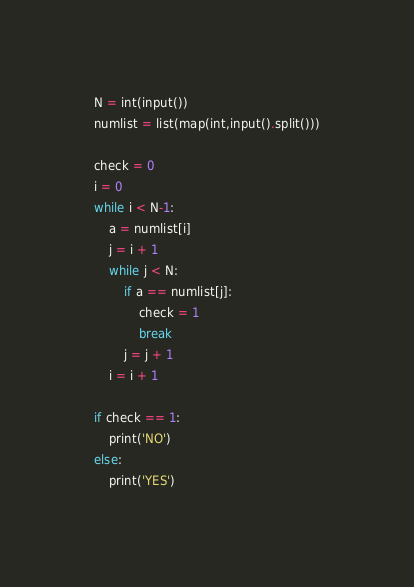Convert code to text. <code><loc_0><loc_0><loc_500><loc_500><_Python_>N = int(input())
numlist = list(map(int,input().split()))

check = 0
i = 0
while i < N-1:
    a = numlist[i]
    j = i + 1
    while j < N:
        if a == numlist[j]:
            check = 1
            break
        j = j + 1
    i = i + 1

if check == 1:
    print('NO')
else:
    print('YES')</code> 